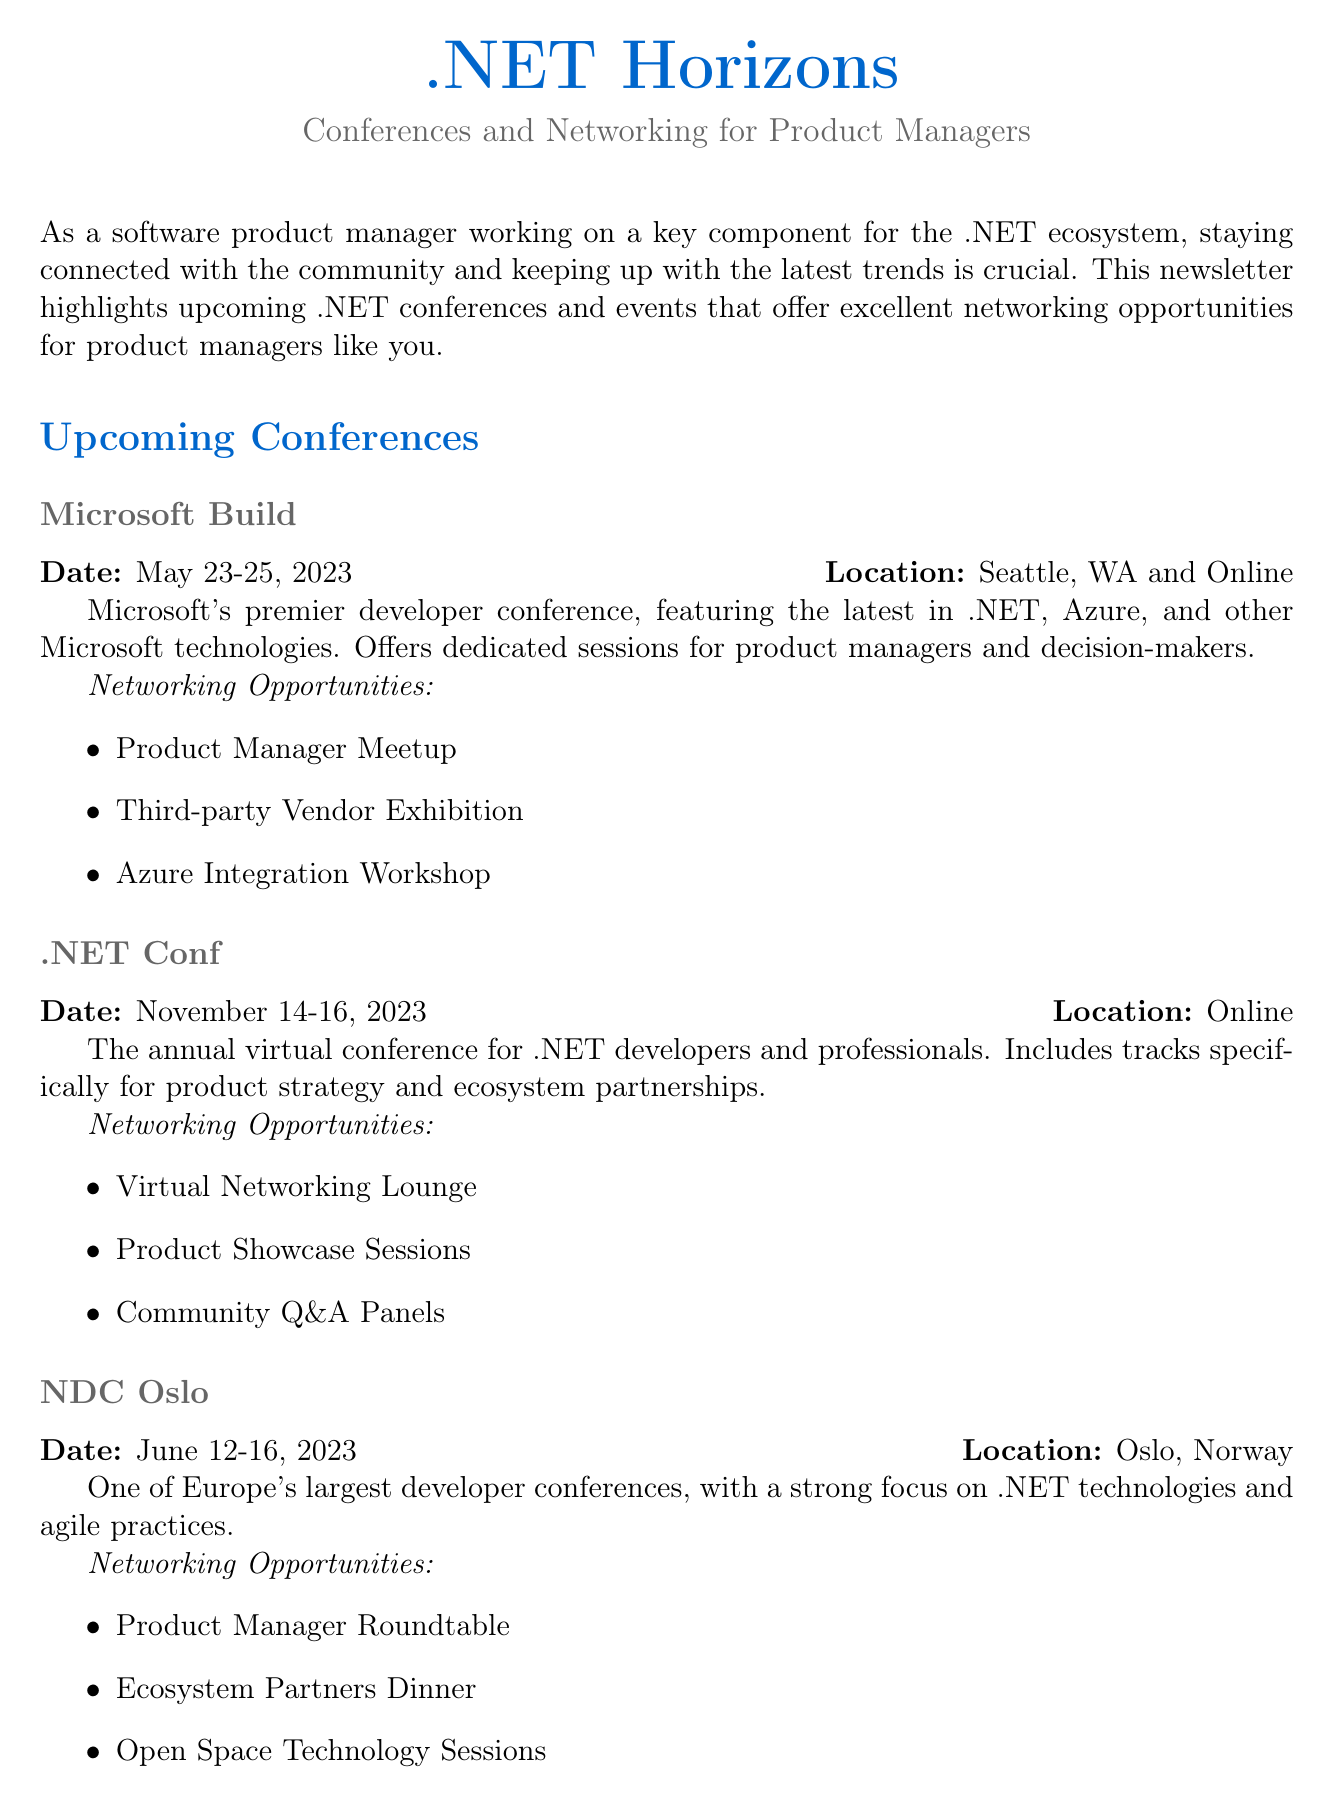what is the title of the newsletter? The title of the newsletter is explicitly stated at the beginning of the document as ".NET Horizons".
Answer: .NET Horizons when is the Microsoft Build conference taking place? The document provides the date for the Microsoft Build conference as May 23-25, 2023.
Answer: May 23-25, 2023 where will the .NET Conf be held? The location for the .NET Conf is noted in the document as Online.
Answer: Online what kind of networking opportunities are offered at NDC Oslo? The document lists specific networking opportunities available at NDC Oslo, including Product Manager Roundtable.
Answer: Product Manager Roundtable what is the main focus of DeveloperWeek? The document indicates that DeveloperWeek has a focused .NET track and networking events for product managers.
Answer: .NET track and networking events for product managers how many industry events are mentioned in the newsletter? The document states that there are two industry events highlighted under the Industry Events section.
Answer: 2 which event occurs first among the upcoming conferences? By reviewing the dates provided, the earliest conference listed is Microsoft Build, taking place in May.
Answer: Microsoft Build what can participants learn about at ProductCon? The relevance section specifies that participants can learn about product management best practices at ProductCon.
Answer: product management best practices what type of document is this? The structure and content of the document, focusing on conferences and networking, indicates it is a newsletter.
Answer: newsletter 